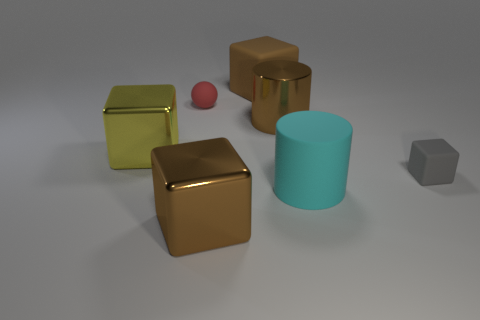There is a shiny thing that is the same color as the big metallic cylinder; what is its size?
Keep it short and to the point. Large. Does the thing that is in front of the big cyan object have the same size as the rubber thing that is to the right of the cyan rubber cylinder?
Your answer should be very brief. No. How many cubes are either big brown metallic things or brown objects?
Give a very brief answer. 2. How many rubber objects are large yellow things or yellow balls?
Make the answer very short. 0. There is a gray thing that is the same shape as the big brown matte object; what size is it?
Provide a succinct answer. Small. There is a cyan object; is it the same size as the thing behind the red object?
Give a very brief answer. Yes. There is a gray object to the right of the shiny cylinder; what is its shape?
Your answer should be compact. Cube. What color is the cube that is left of the thing that is in front of the cyan rubber cylinder?
Offer a terse response. Yellow. What color is the other large thing that is the same shape as the cyan thing?
Offer a very short reply. Brown. How many tiny rubber cubes have the same color as the large metallic cylinder?
Offer a very short reply. 0. 